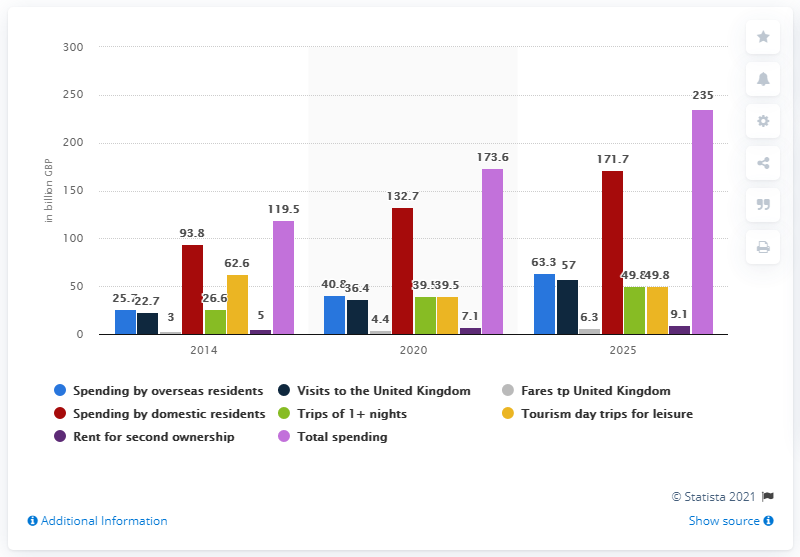What can we infer about the future spending projections for domestic residents from 2020 to 2025 according to this data? According to the future projections on the graph, it's estimated that the spending by domestic residents will significantly increase to about 171.7 billion GBP by 2025, indicating a positive trend and increasing economic engagement within the UK. 